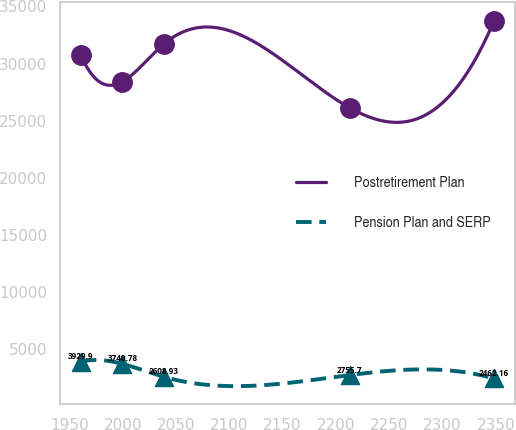Convert chart to OTSL. <chart><loc_0><loc_0><loc_500><loc_500><line_chart><ecel><fcel>Postretirement Plan<fcel>Pension Plan and SERP<nl><fcel>1960.81<fcel>30708.5<fcel>3929.9<nl><fcel>1999.58<fcel>28402.3<fcel>3740.78<nl><fcel>2038.35<fcel>31688.5<fcel>2608.93<nl><fcel>2212.92<fcel>26133.1<fcel>2755.7<nl><fcel>2348.49<fcel>33753.9<fcel>2462.16<nl></chart> 